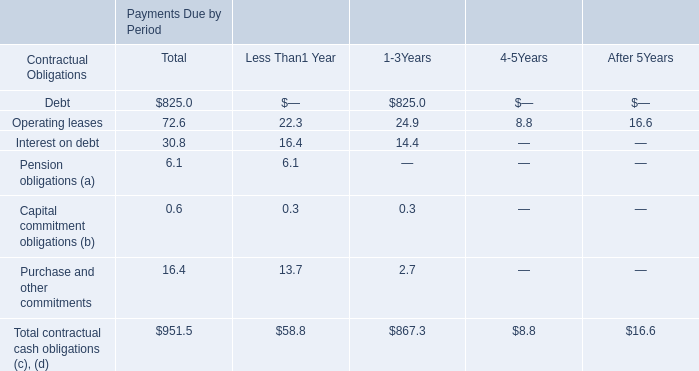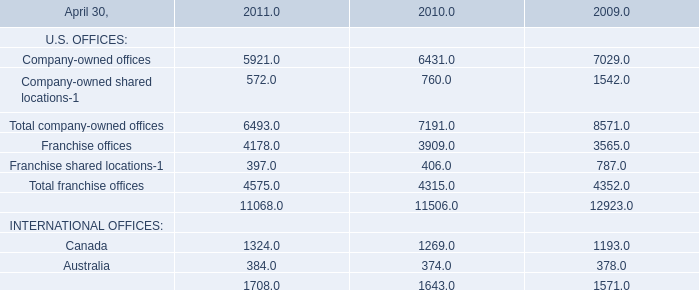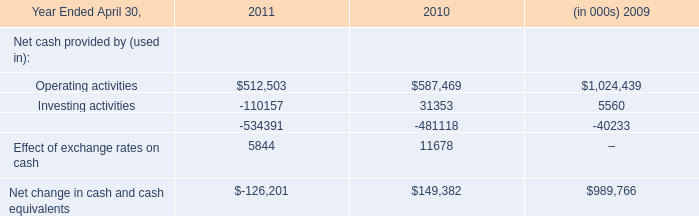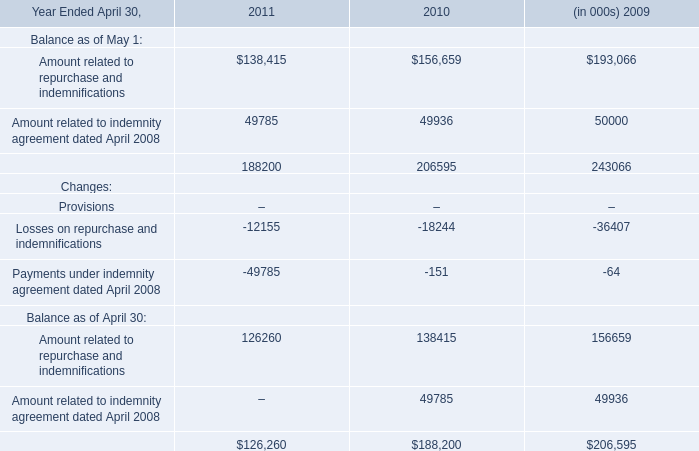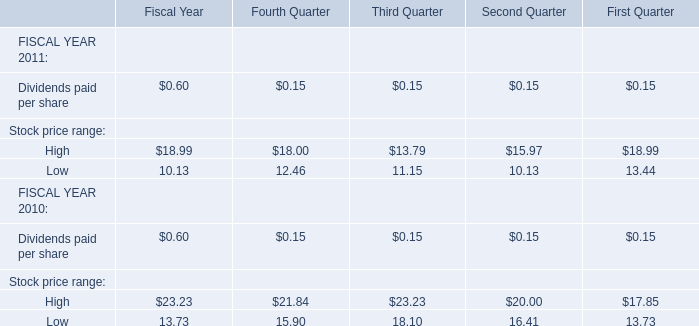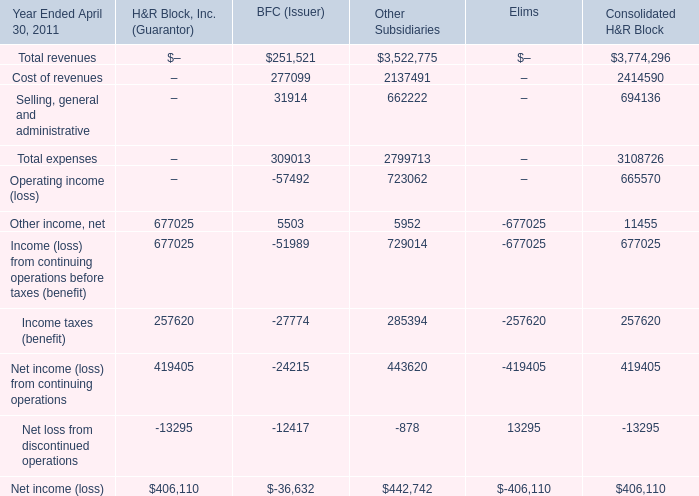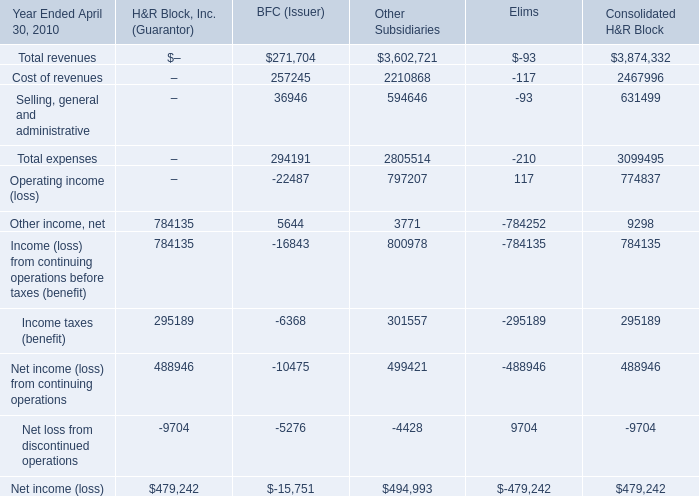What is the sum of Dividends paid per share ,Stock price range's High and Stock price range's Low in 2011 for Third Quarter? 
Computations: ((0.15 + 13.79) + 11.15)
Answer: 25.09. 